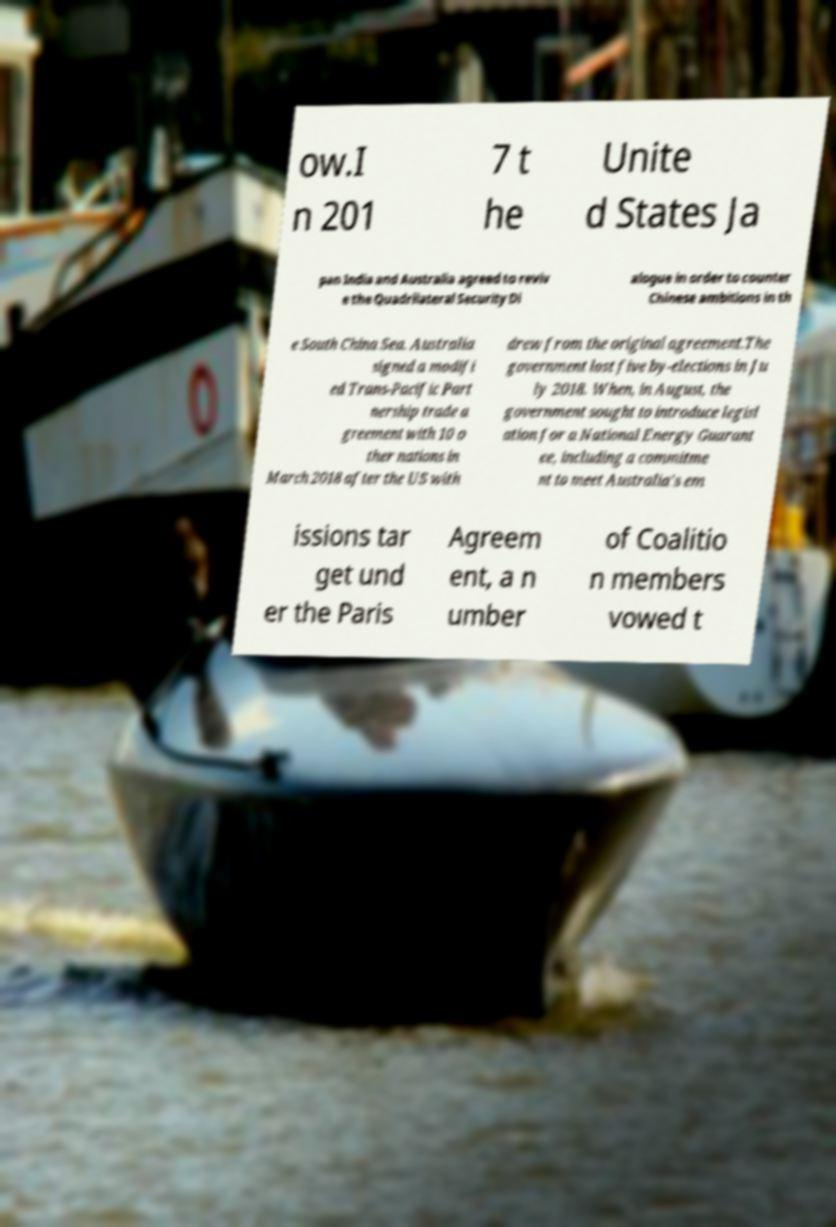There's text embedded in this image that I need extracted. Can you transcribe it verbatim? ow.I n 201 7 t he Unite d States Ja pan India and Australia agreed to reviv e the Quadrilateral Security Di alogue in order to counter Chinese ambitions in th e South China Sea. Australia signed a modifi ed Trans-Pacific Part nership trade a greement with 10 o ther nations in March 2018 after the US with drew from the original agreement.The government lost five by-elections in Ju ly 2018. When, in August, the government sought to introduce legisl ation for a National Energy Guarant ee, including a commitme nt to meet Australia's em issions tar get und er the Paris Agreem ent, a n umber of Coalitio n members vowed t 